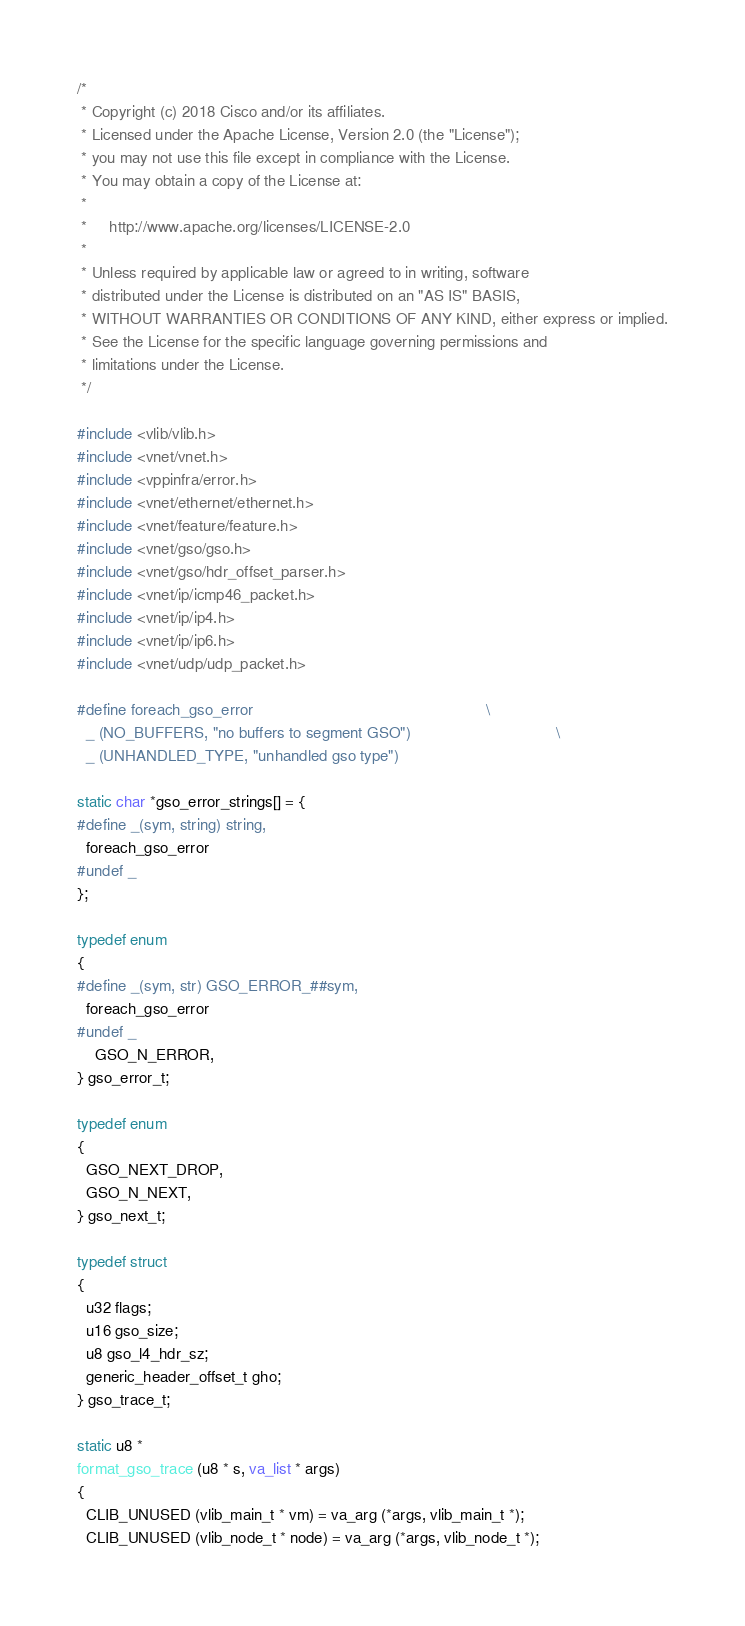<code> <loc_0><loc_0><loc_500><loc_500><_C_>/*
 * Copyright (c) 2018 Cisco and/or its affiliates.
 * Licensed under the Apache License, Version 2.0 (the "License");
 * you may not use this file except in compliance with the License.
 * You may obtain a copy of the License at:
 *
 *     http://www.apache.org/licenses/LICENSE-2.0
 *
 * Unless required by applicable law or agreed to in writing, software
 * distributed under the License is distributed on an "AS IS" BASIS,
 * WITHOUT WARRANTIES OR CONDITIONS OF ANY KIND, either express or implied.
 * See the License for the specific language governing permissions and
 * limitations under the License.
 */

#include <vlib/vlib.h>
#include <vnet/vnet.h>
#include <vppinfra/error.h>
#include <vnet/ethernet/ethernet.h>
#include <vnet/feature/feature.h>
#include <vnet/gso/gso.h>
#include <vnet/gso/hdr_offset_parser.h>
#include <vnet/ip/icmp46_packet.h>
#include <vnet/ip/ip4.h>
#include <vnet/ip/ip6.h>
#include <vnet/udp/udp_packet.h>

#define foreach_gso_error                                                     \
  _ (NO_BUFFERS, "no buffers to segment GSO")                                 \
  _ (UNHANDLED_TYPE, "unhandled gso type")

static char *gso_error_strings[] = {
#define _(sym, string) string,
  foreach_gso_error
#undef _
};

typedef enum
{
#define _(sym, str) GSO_ERROR_##sym,
  foreach_gso_error
#undef _
    GSO_N_ERROR,
} gso_error_t;

typedef enum
{
  GSO_NEXT_DROP,
  GSO_N_NEXT,
} gso_next_t;

typedef struct
{
  u32 flags;
  u16 gso_size;
  u8 gso_l4_hdr_sz;
  generic_header_offset_t gho;
} gso_trace_t;

static u8 *
format_gso_trace (u8 * s, va_list * args)
{
  CLIB_UNUSED (vlib_main_t * vm) = va_arg (*args, vlib_main_t *);
  CLIB_UNUSED (vlib_node_t * node) = va_arg (*args, vlib_node_t *);</code> 